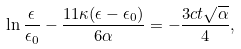<formula> <loc_0><loc_0><loc_500><loc_500>\ln \frac { \epsilon } { \epsilon _ { 0 } } - \frac { 1 1 \kappa ( \epsilon - \epsilon _ { 0 } ) } { 6 \alpha } = - \frac { 3 c t \sqrt { \alpha } } { 4 } ,</formula> 